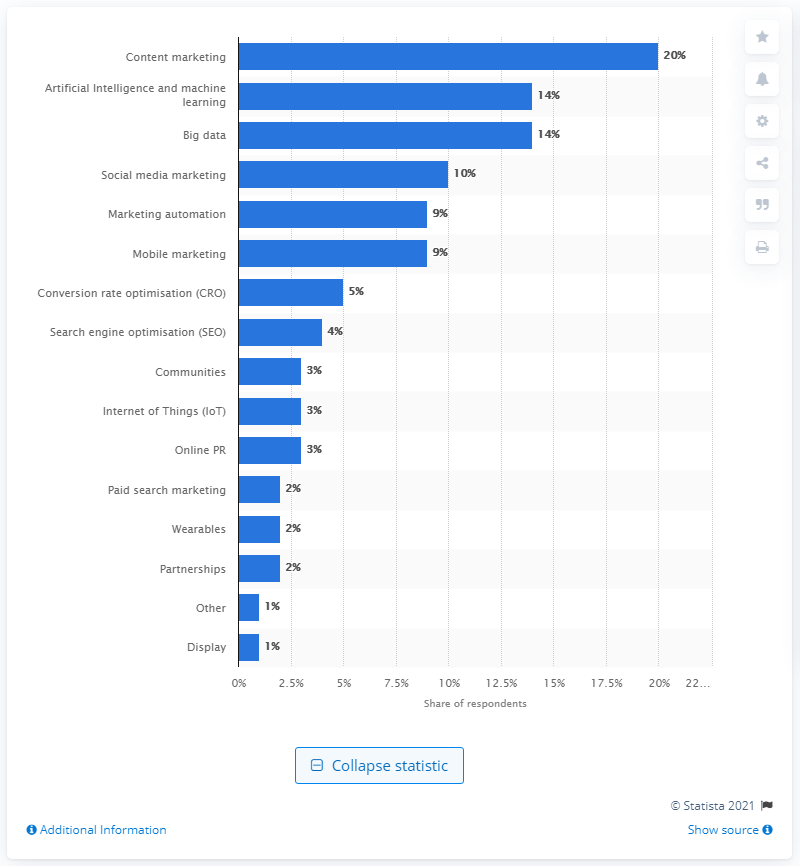Identify some key points in this picture. According to the responses of global marketers in early 2018, content marketing was deemed to be the most effective digital technique. According to a survey of marketers, 20% reported that content marketing was the most effective digital technique they used. 